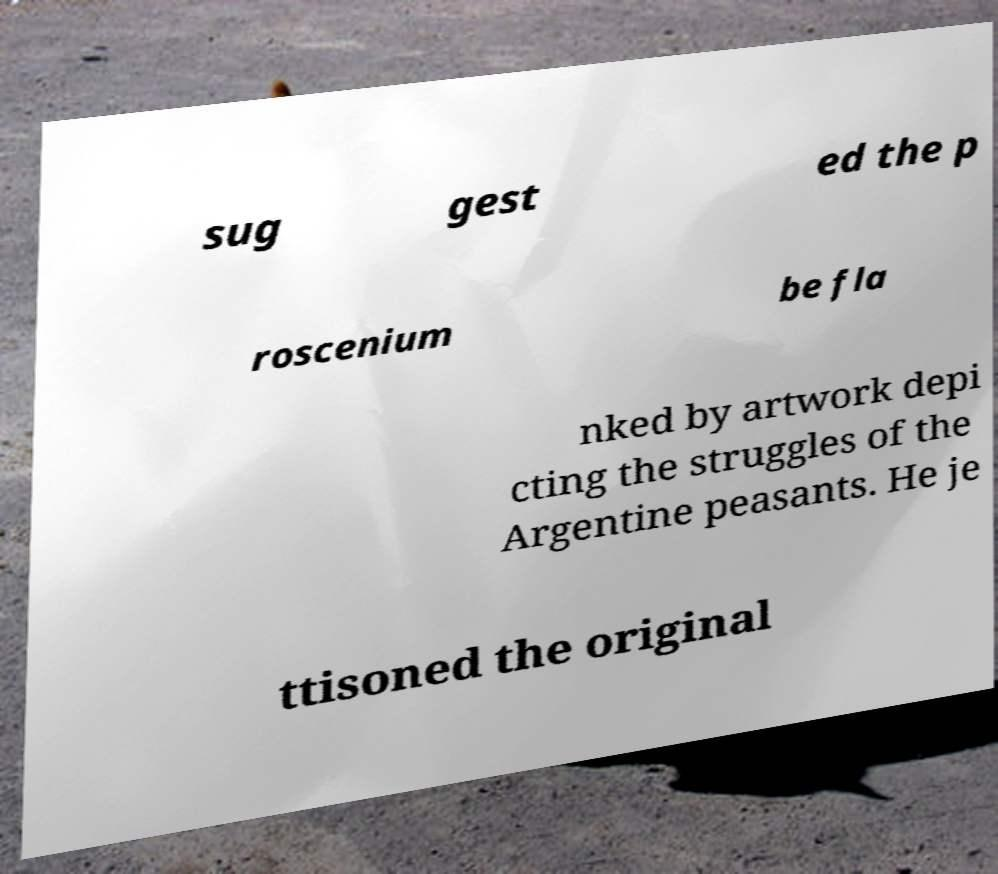I need the written content from this picture converted into text. Can you do that? sug gest ed the p roscenium be fla nked by artwork depi cting the struggles of the Argentine peasants. He je ttisoned the original 